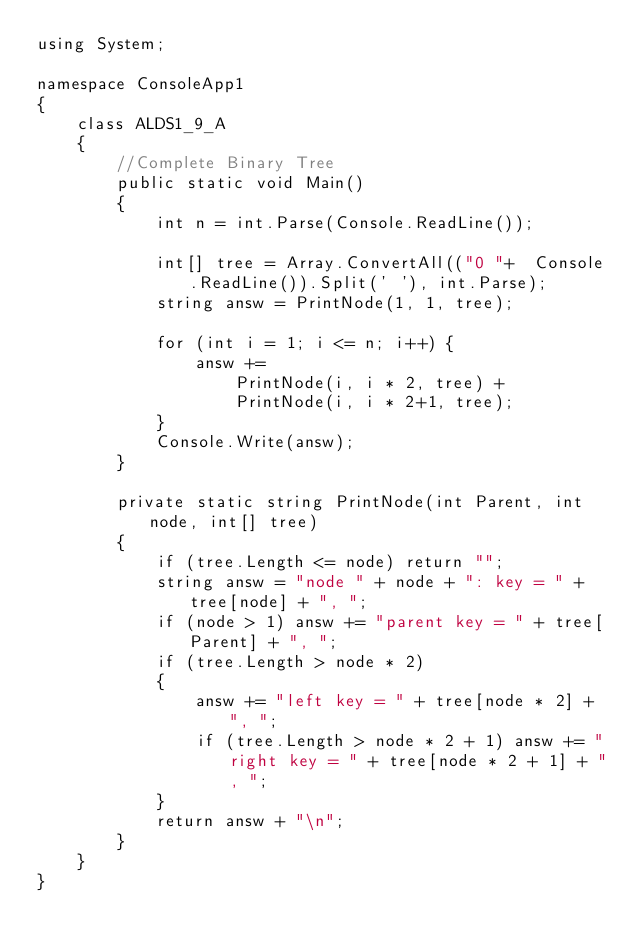<code> <loc_0><loc_0><loc_500><loc_500><_C#_>using System;

namespace ConsoleApp1
{
    class ALDS1_9_A
    {
        //Complete Binary Tree
        public static void Main() 
        {
            int n = int.Parse(Console.ReadLine());

            int[] tree = Array.ConvertAll(("0 "+  Console.ReadLine()).Split(' '), int.Parse);
            string answ = PrintNode(1, 1, tree);

            for (int i = 1; i <= n; i++) {
                answ +=
                    PrintNode(i, i * 2, tree) +
                    PrintNode(i, i * 2+1, tree);
            }
            Console.Write(answ);
        }

        private static string PrintNode(int Parent, int node, int[] tree) 
        {
            if (tree.Length <= node) return "";
            string answ = "node " + node + ": key = " + tree[node] + ", ";
            if (node > 1) answ += "parent key = " + tree[Parent] + ", ";
            if (tree.Length > node * 2)
            { 
                answ += "left key = " + tree[node * 2] + ", ";
                if (tree.Length > node * 2 + 1) answ += "right key = " + tree[node * 2 + 1] + ", ";
            }
            return answ + "\n";
        }
    }
}

</code> 